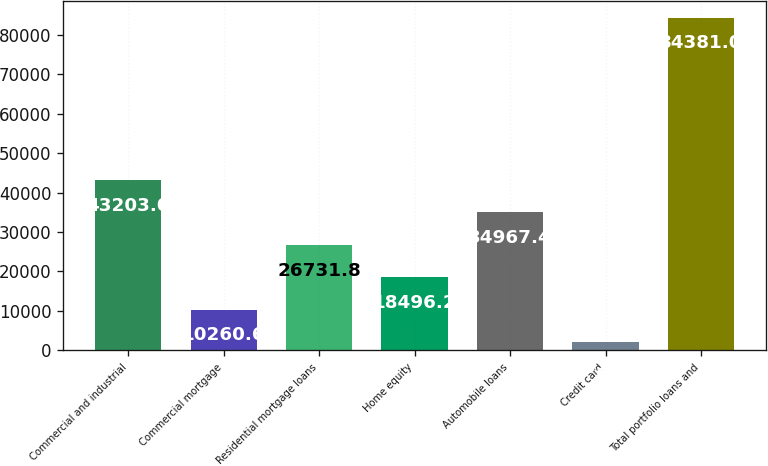Convert chart. <chart><loc_0><loc_0><loc_500><loc_500><bar_chart><fcel>Commercial and industrial<fcel>Commercial mortgage<fcel>Residential mortgage loans<fcel>Home equity<fcel>Automobile loans<fcel>Credit card<fcel>Total portfolio loans and<nl><fcel>43203<fcel>10260.6<fcel>26731.8<fcel>18496.2<fcel>34967.4<fcel>2025<fcel>84381<nl></chart> 